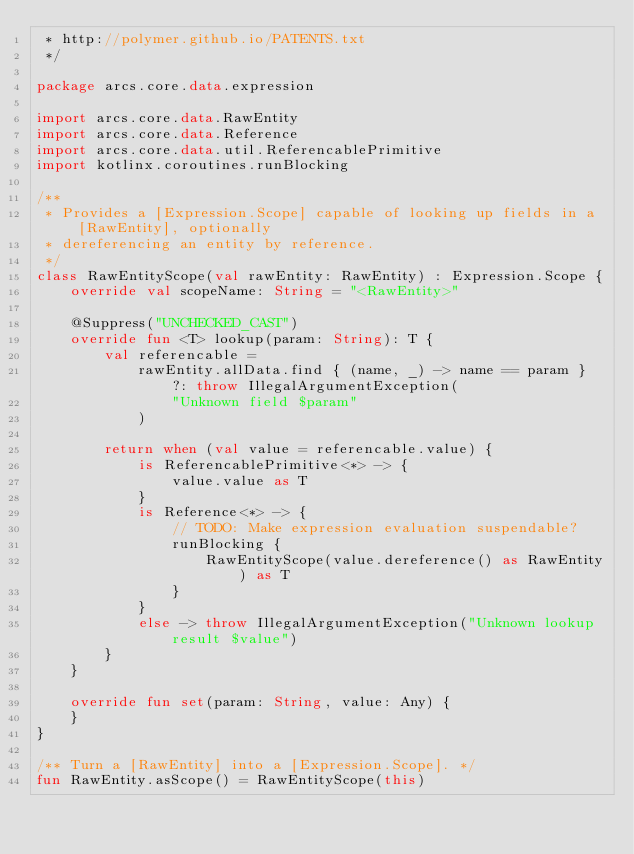Convert code to text. <code><loc_0><loc_0><loc_500><loc_500><_Kotlin_> * http://polymer.github.io/PATENTS.txt
 */

package arcs.core.data.expression

import arcs.core.data.RawEntity
import arcs.core.data.Reference
import arcs.core.data.util.ReferencablePrimitive
import kotlinx.coroutines.runBlocking

/**
 * Provides a [Expression.Scope] capable of looking up fields in a [RawEntity], optionally
 * dereferencing an entity by reference.
 */
class RawEntityScope(val rawEntity: RawEntity) : Expression.Scope {
    override val scopeName: String = "<RawEntity>"

    @Suppress("UNCHECKED_CAST")
    override fun <T> lookup(param: String): T {
        val referencable =
            rawEntity.allData.find { (name, _) -> name == param } ?: throw IllegalArgumentException(
                "Unknown field $param"
            )

        return when (val value = referencable.value) {
            is ReferencablePrimitive<*> -> {
                value.value as T
            }
            is Reference<*> -> {
                // TODO: Make expression evaluation suspendable?
                runBlocking {
                    RawEntityScope(value.dereference() as RawEntity) as T
                }
            }
            else -> throw IllegalArgumentException("Unknown lookup result $value")
        }
    }

    override fun set(param: String, value: Any) {
    }
}

/** Turn a [RawEntity] into a [Expression.Scope]. */
fun RawEntity.asScope() = RawEntityScope(this)
</code> 